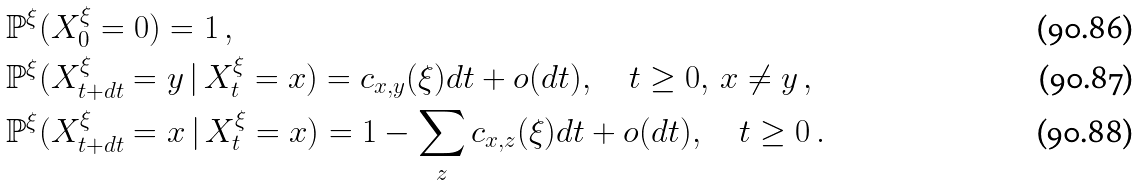<formula> <loc_0><loc_0><loc_500><loc_500>& \mathbb { P } ^ { \xi } ( X ^ { \xi } _ { 0 } = 0 ) = 1 \, , \\ & \mathbb { P } ^ { \xi } ( X ^ { \xi } _ { t + d t } = y \, | \, X ^ { \xi } _ { t } = x ) = c _ { x , y } ( \xi ) d t + o ( d t ) , \quad t \geq 0 , \, x \neq y \, , \\ & \mathbb { P } ^ { \xi } ( X ^ { \xi } _ { t + d t } = x \, | \, X ^ { \xi } _ { t } = x ) = 1 - \sum _ { z } c _ { x , z } ( \xi ) d t + o ( d t ) , \quad t \geq 0 \, .</formula> 